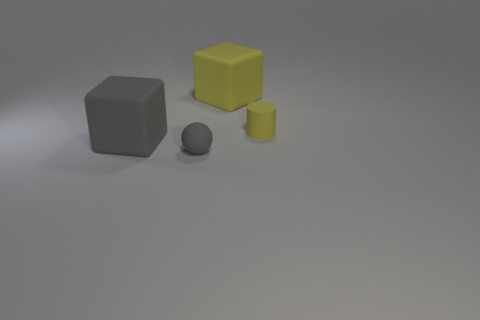If I were to stack these objects, which order would result in the most stable configuration? To achieve the most stable stack, you would place the largest gray cube at the bottom, followed by the yellow cube, then the yellow cylinder, and finally the sphere on top, given its round shape would not support any additional weight stably. 